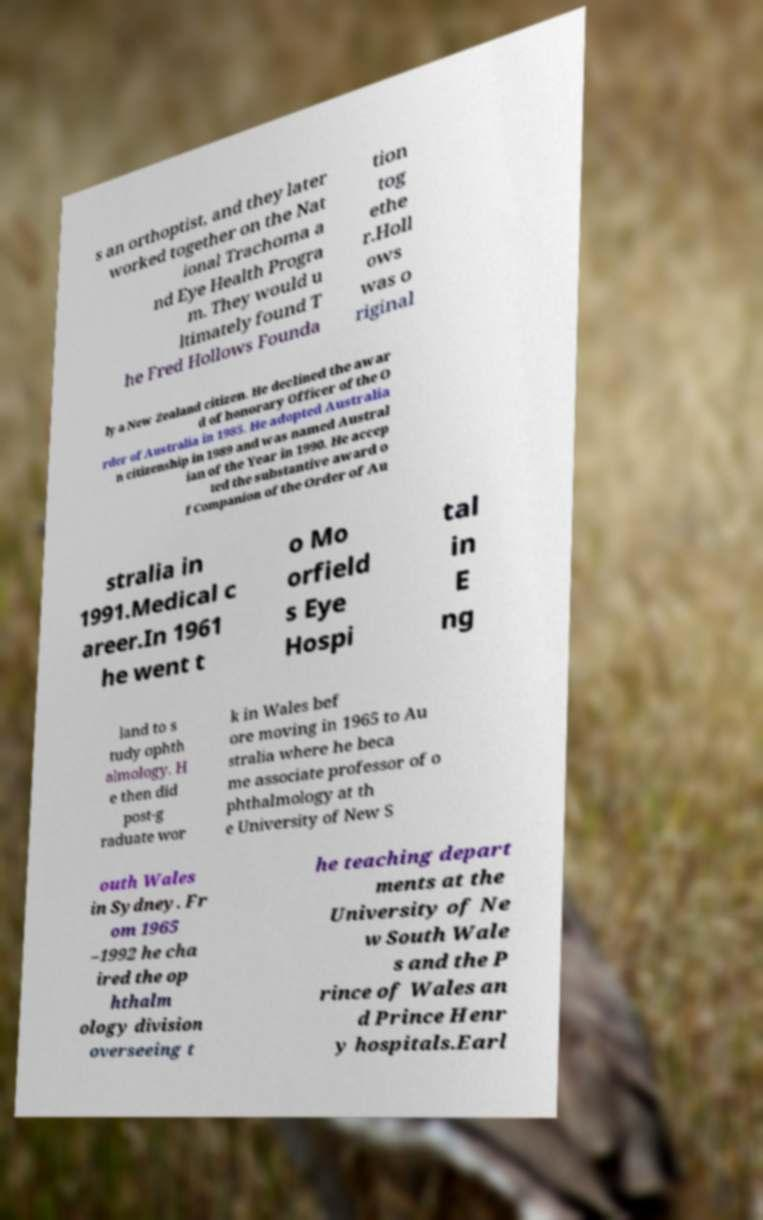Can you accurately transcribe the text from the provided image for me? s an orthoptist, and they later worked together on the Nat ional Trachoma a nd Eye Health Progra m. They would u ltimately found T he Fred Hollows Founda tion tog ethe r.Holl ows was o riginal ly a New Zealand citizen. He declined the awar d of honorary Officer of the O rder of Australia in 1985. He adopted Australia n citizenship in 1989 and was named Austral ian of the Year in 1990. He accep ted the substantive award o f Companion of the Order of Au stralia in 1991.Medical c areer.In 1961 he went t o Mo orfield s Eye Hospi tal in E ng land to s tudy ophth almology. H e then did post-g raduate wor k in Wales bef ore moving in 1965 to Au stralia where he beca me associate professor of o phthalmology at th e University of New S outh Wales in Sydney. Fr om 1965 –1992 he cha ired the op hthalm ology division overseeing t he teaching depart ments at the University of Ne w South Wale s and the P rince of Wales an d Prince Henr y hospitals.Earl 